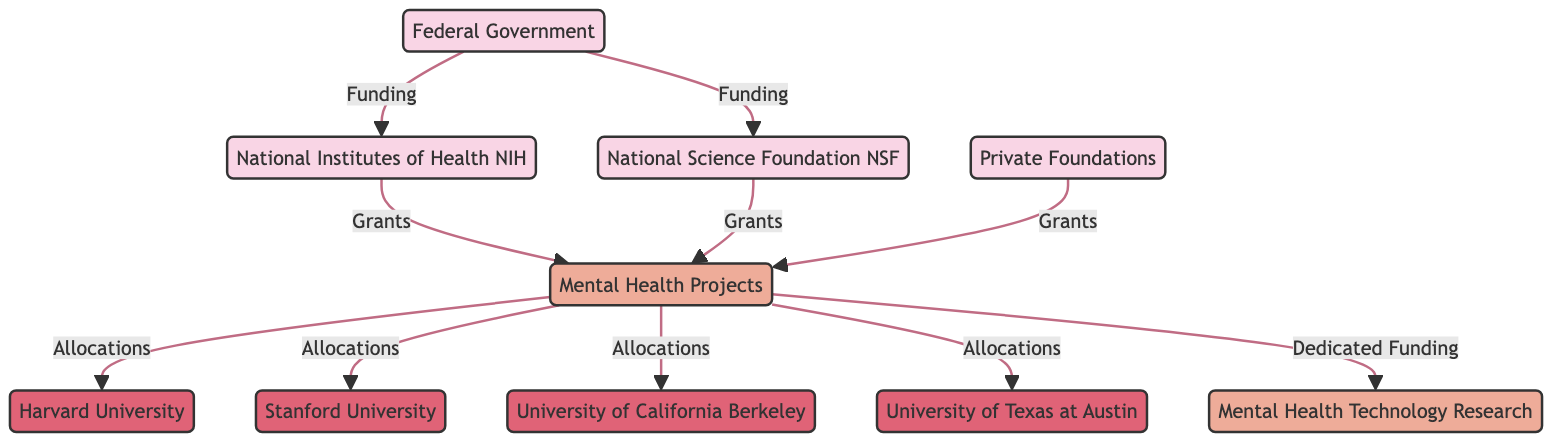What entities provide funding for mental health projects? The diagram shows that the funding for mental health projects comes from three entities: the Federal Government, Private Foundations, and the National Institutes of Health (NIH). Each of these entities is connected to the mental health projects in the diagram.
Answer: Federal Government, Private Foundations, National Institutes of Health How many universities receive allocations from mental health projects? In the diagram, there are four institutions listed that receive allocations from mental health projects: Harvard University, Stanford University, University of California Berkeley, and University of Texas at Austin. Counting these institutions gives the total.
Answer: 4 What type of research is specifically dedicated funding for according to the diagram? The diagram indicates that there is dedicated funding for Mental Health Technology Research, which is explicitly mentioned as a separate node connected to the mental health projects.
Answer: Mental Health Technology Research Which entity connects directly to the National Institutes of Health? The diagram shows that the Federal Government connects directly to the National Institutes of Health (NIH) through the funding relationship. Therefore, the Federal Government is the entity that provides support.
Answer: Federal Government What is the relationship between the National Science Foundation and mental health projects? The relationship illustrated in the diagram between the National Science Foundation (NSF) and mental health projects is that of funding provided by NSF, which is shown as a directed connection indicating an inflow of support.
Answer: Grants Which university does not receive funding from mental health projects according to the diagram? The diagram specifically lists all the universities that receive allocations, which are Harvard, Stanford, Berkeley, and Texas at Austin. Any university not mentioned in this list does not receive funding.
Answer: None, all listed receive funding 